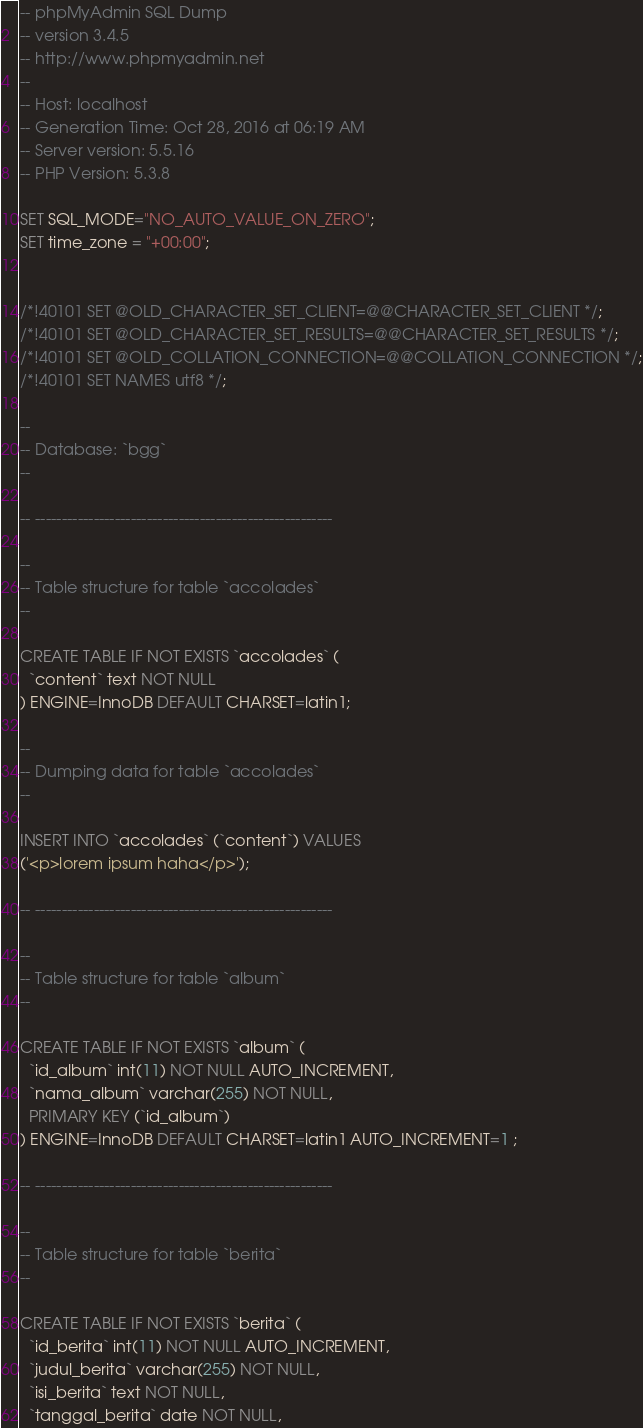Convert code to text. <code><loc_0><loc_0><loc_500><loc_500><_SQL_>-- phpMyAdmin SQL Dump
-- version 3.4.5
-- http://www.phpmyadmin.net
--
-- Host: localhost
-- Generation Time: Oct 28, 2016 at 06:19 AM
-- Server version: 5.5.16
-- PHP Version: 5.3.8

SET SQL_MODE="NO_AUTO_VALUE_ON_ZERO";
SET time_zone = "+00:00";


/*!40101 SET @OLD_CHARACTER_SET_CLIENT=@@CHARACTER_SET_CLIENT */;
/*!40101 SET @OLD_CHARACTER_SET_RESULTS=@@CHARACTER_SET_RESULTS */;
/*!40101 SET @OLD_COLLATION_CONNECTION=@@COLLATION_CONNECTION */;
/*!40101 SET NAMES utf8 */;

--
-- Database: `bgg`
--

-- --------------------------------------------------------

--
-- Table structure for table `accolades`
--

CREATE TABLE IF NOT EXISTS `accolades` (
  `content` text NOT NULL
) ENGINE=InnoDB DEFAULT CHARSET=latin1;

--
-- Dumping data for table `accolades`
--

INSERT INTO `accolades` (`content`) VALUES
('<p>lorem ipsum haha</p>');

-- --------------------------------------------------------

--
-- Table structure for table `album`
--

CREATE TABLE IF NOT EXISTS `album` (
  `id_album` int(11) NOT NULL AUTO_INCREMENT,
  `nama_album` varchar(255) NOT NULL,
  PRIMARY KEY (`id_album`)
) ENGINE=InnoDB DEFAULT CHARSET=latin1 AUTO_INCREMENT=1 ;

-- --------------------------------------------------------

--
-- Table structure for table `berita`
--

CREATE TABLE IF NOT EXISTS `berita` (
  `id_berita` int(11) NOT NULL AUTO_INCREMENT,
  `judul_berita` varchar(255) NOT NULL,
  `isi_berita` text NOT NULL,
  `tanggal_berita` date NOT NULL,</code> 